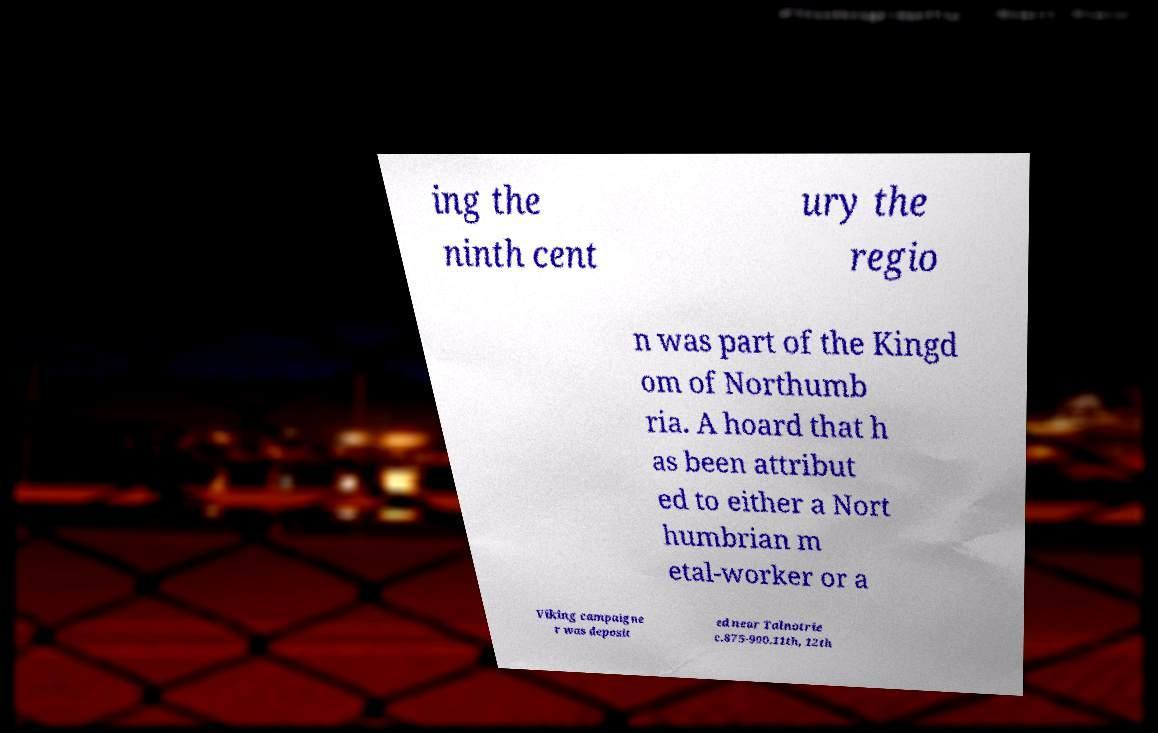There's text embedded in this image that I need extracted. Can you transcribe it verbatim? ing the ninth cent ury the regio n was part of the Kingd om of Northumb ria. A hoard that h as been attribut ed to either a Nort humbrian m etal-worker or a Viking campaigne r was deposit ed near Talnotrie c.875-900.11th, 12th 